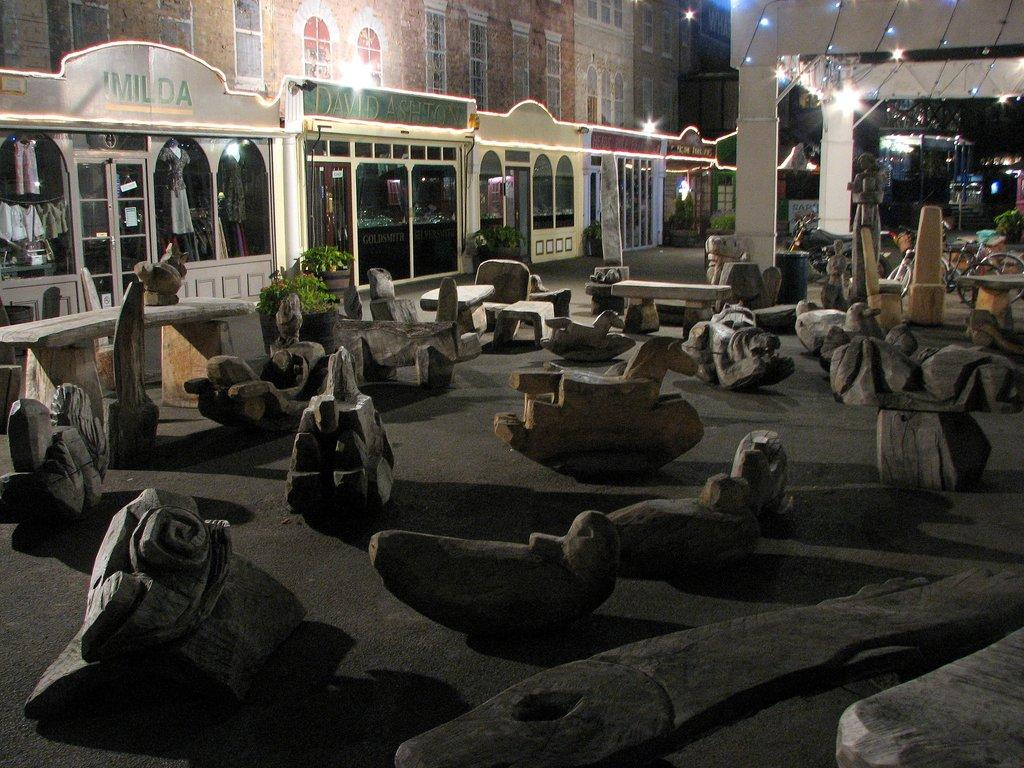What type of surface is visible in the image? There is ground visible in the image. What can be found on the ground in the image? There are sculptures on the ground. What type of seating is present in the image? There are benches in the image. What type of vegetation is present in the image? There are trees in the image. What type of transportation is present in the image? There are vehicles in the image. What type of structures are present in the image? There are buildings in the image. What type of illumination is present on the buildings? There are lights on the buildings. Where is the hydrant located in the image? There is no hydrant present in the image. What type of meat is being grilled on the benches in the image? There is no meat or grilling activity present in the image. 